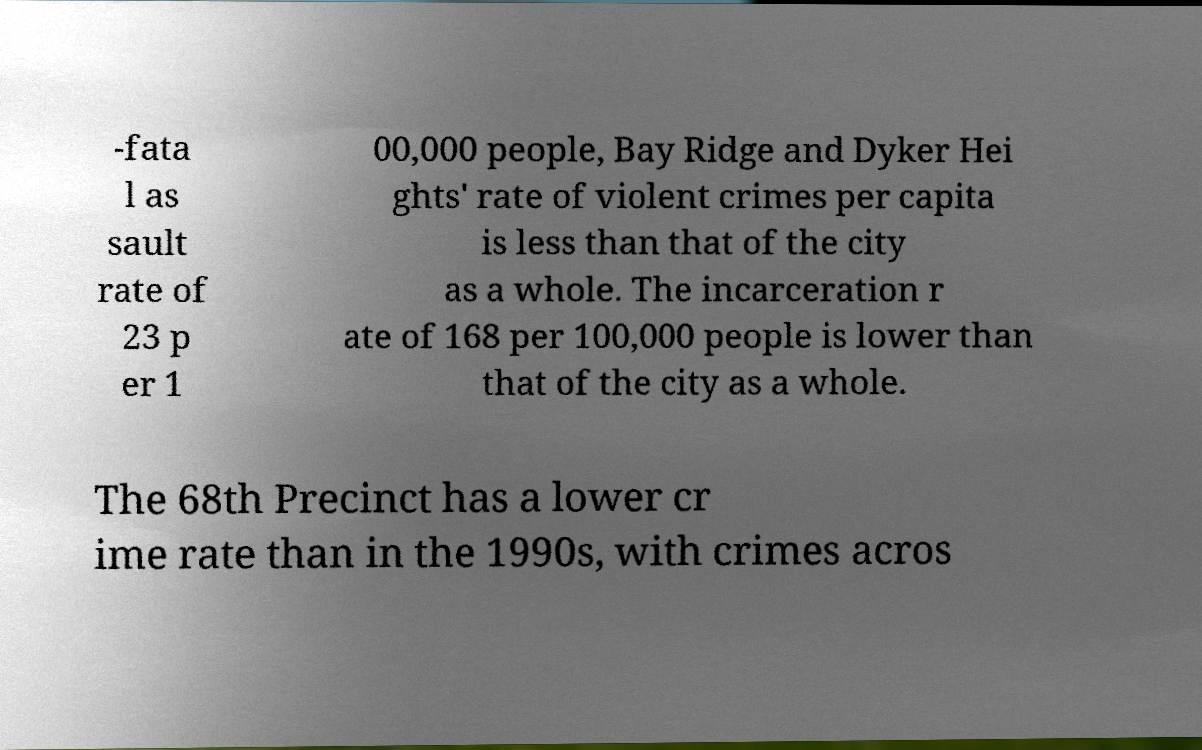Could you extract and type out the text from this image? -fata l as sault rate of 23 p er 1 00,000 people, Bay Ridge and Dyker Hei ghts' rate of violent crimes per capita is less than that of the city as a whole. The incarceration r ate of 168 per 100,000 people is lower than that of the city as a whole. The 68th Precinct has a lower cr ime rate than in the 1990s, with crimes acros 